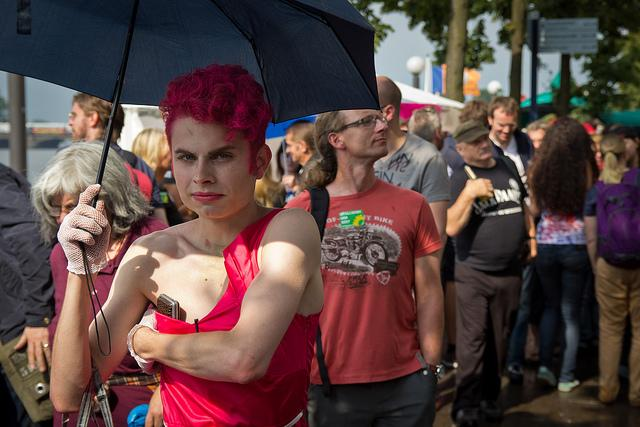Why does the man holding the umbrella have very red lips? Please explain your reasoning. lipstick. This kind of look comes from applying lipstick on to make them red. 